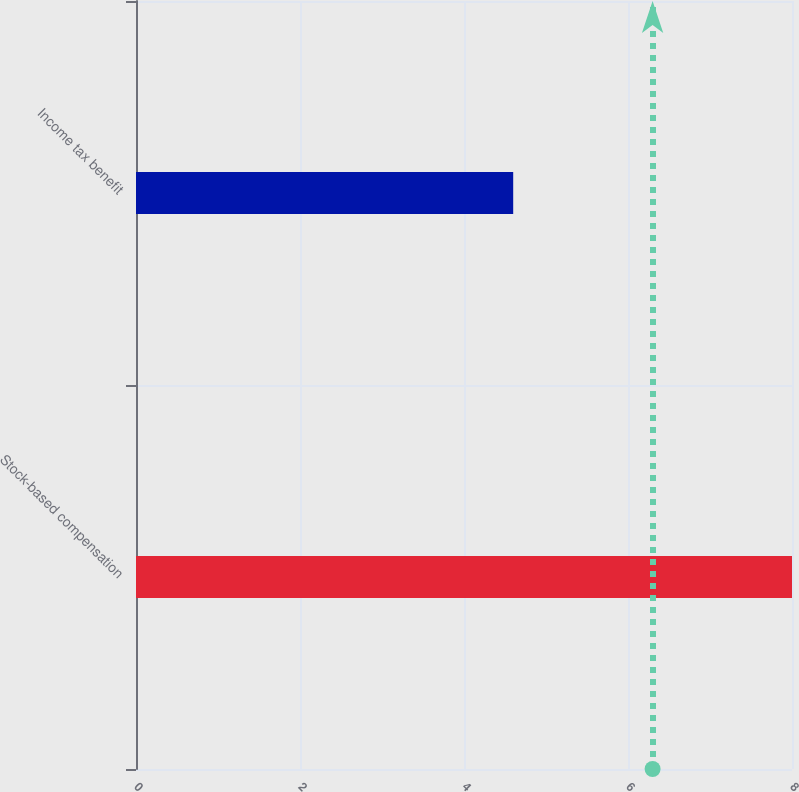<chart> <loc_0><loc_0><loc_500><loc_500><bar_chart><fcel>Stock-based compensation<fcel>Income tax benefit<nl><fcel>8<fcel>4.6<nl></chart> 